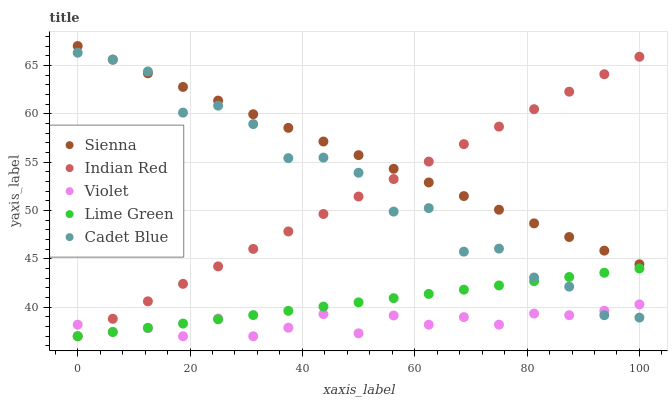Does Violet have the minimum area under the curve?
Answer yes or no. Yes. Does Sienna have the maximum area under the curve?
Answer yes or no. Yes. Does Cadet Blue have the minimum area under the curve?
Answer yes or no. No. Does Cadet Blue have the maximum area under the curve?
Answer yes or no. No. Is Lime Green the smoothest?
Answer yes or no. Yes. Is Cadet Blue the roughest?
Answer yes or no. Yes. Is Cadet Blue the smoothest?
Answer yes or no. No. Is Lime Green the roughest?
Answer yes or no. No. Does Lime Green have the lowest value?
Answer yes or no. Yes. Does Cadet Blue have the lowest value?
Answer yes or no. No. Does Sienna have the highest value?
Answer yes or no. Yes. Does Cadet Blue have the highest value?
Answer yes or no. No. Is Lime Green less than Sienna?
Answer yes or no. Yes. Is Sienna greater than Lime Green?
Answer yes or no. Yes. Does Sienna intersect Indian Red?
Answer yes or no. Yes. Is Sienna less than Indian Red?
Answer yes or no. No. Is Sienna greater than Indian Red?
Answer yes or no. No. Does Lime Green intersect Sienna?
Answer yes or no. No. 